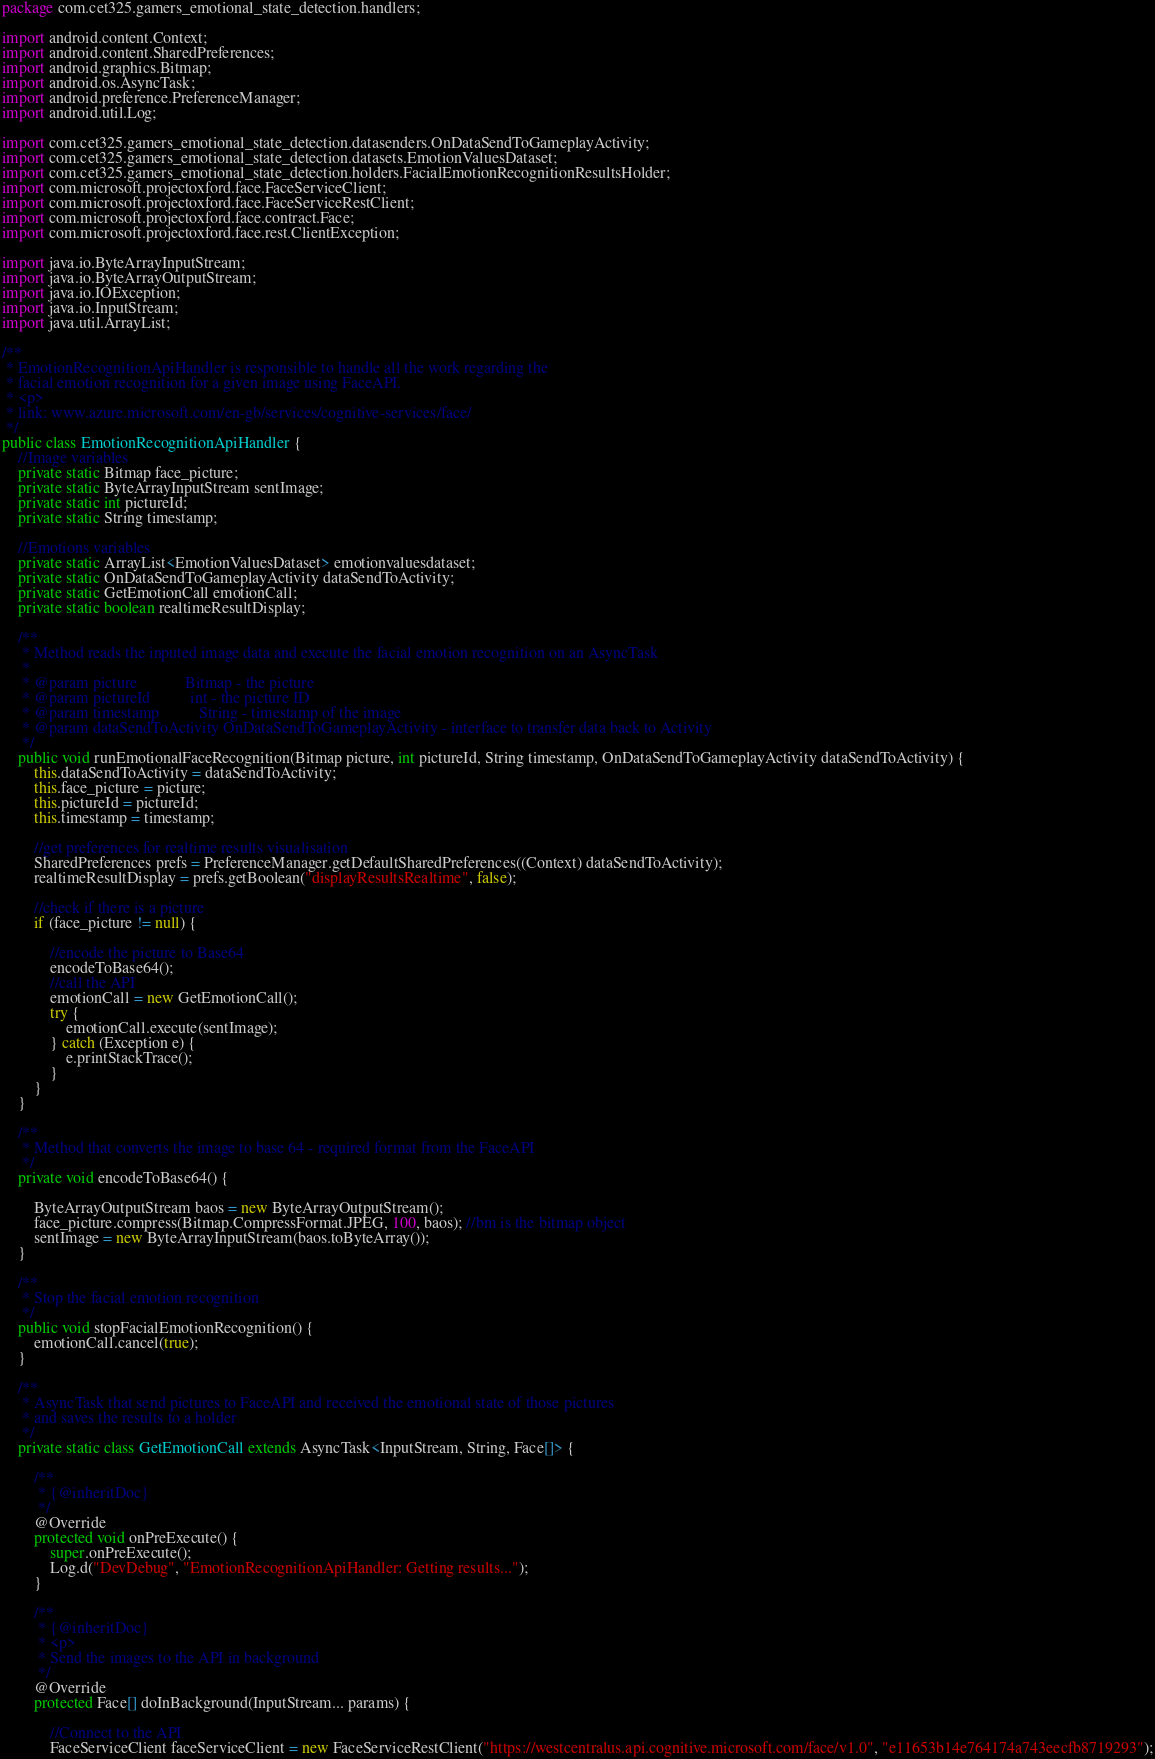Convert code to text. <code><loc_0><loc_0><loc_500><loc_500><_Java_>package com.cet325.gamers_emotional_state_detection.handlers;

import android.content.Context;
import android.content.SharedPreferences;
import android.graphics.Bitmap;
import android.os.AsyncTask;
import android.preference.PreferenceManager;
import android.util.Log;

import com.cet325.gamers_emotional_state_detection.datasenders.OnDataSendToGameplayActivity;
import com.cet325.gamers_emotional_state_detection.datasets.EmotionValuesDataset;
import com.cet325.gamers_emotional_state_detection.holders.FacialEmotionRecognitionResultsHolder;
import com.microsoft.projectoxford.face.FaceServiceClient;
import com.microsoft.projectoxford.face.FaceServiceRestClient;
import com.microsoft.projectoxford.face.contract.Face;
import com.microsoft.projectoxford.face.rest.ClientException;

import java.io.ByteArrayInputStream;
import java.io.ByteArrayOutputStream;
import java.io.IOException;
import java.io.InputStream;
import java.util.ArrayList;

/**
 * EmotionRecognitionApiHandler is responsible to handle all the work regarding the
 * facial emotion recognition for a given image using FaceAPI.
 * <p>
 * link: www.azure.microsoft.com/en-gb/services/cognitive-services/face/
 */
public class EmotionRecognitionApiHandler {
    //Image variables
    private static Bitmap face_picture;
    private static ByteArrayInputStream sentImage;
    private static int pictureId;
    private static String timestamp;

    //Emotions variables
    private static ArrayList<EmotionValuesDataset> emotionvaluesdataset;
    private static OnDataSendToGameplayActivity dataSendToActivity;
    private static GetEmotionCall emotionCall;
    private static boolean realtimeResultDisplay;

    /**
     * Method reads the inputed image data and execute the facial emotion recognition on an AsyncTask
     *
     * @param picture            Bitmap - the picture
     * @param pictureId          int - the picture ID
     * @param timestamp          String - timestamp of the image
     * @param dataSendToActivity OnDataSendToGameplayActivity - interface to transfer data back to Activity
     */
    public void runEmotionalFaceRecognition(Bitmap picture, int pictureId, String timestamp, OnDataSendToGameplayActivity dataSendToActivity) {
        this.dataSendToActivity = dataSendToActivity;
        this.face_picture = picture;
        this.pictureId = pictureId;
        this.timestamp = timestamp;

        //get preferences for realtime results visualisation
        SharedPreferences prefs = PreferenceManager.getDefaultSharedPreferences((Context) dataSendToActivity);
        realtimeResultDisplay = prefs.getBoolean("displayResultsRealtime", false);

        //check if there is a picture
        if (face_picture != null) {

            //encode the picture to Base64
            encodeToBase64();
            //call the API
            emotionCall = new GetEmotionCall();
            try {
                emotionCall.execute(sentImage);
            } catch (Exception e) {
                e.printStackTrace();
            }
        }
    }

    /**
     * Method that converts the image to base 64 - required format from the FaceAPI
     */
    private void encodeToBase64() {

        ByteArrayOutputStream baos = new ByteArrayOutputStream();
        face_picture.compress(Bitmap.CompressFormat.JPEG, 100, baos); //bm is the bitmap object
        sentImage = new ByteArrayInputStream(baos.toByteArray());
    }

    /**
     * Stop the facial emotion recognition
     */
    public void stopFacialEmotionRecognition() {
        emotionCall.cancel(true);
    }

    /**
     * AsyncTask that send pictures to FaceAPI and received the emotional state of those pictures
     * and saves the results to a holder
     */
    private static class GetEmotionCall extends AsyncTask<InputStream, String, Face[]> {

        /**
         * {@inheritDoc}
         */
        @Override
        protected void onPreExecute() {
            super.onPreExecute();
            Log.d("DevDebug", "EmotionRecognitionApiHandler: Getting results...");
        }

        /**
         * {@inheritDoc}
         * <p>
         * Send the images to the API in background
         */
        @Override
        protected Face[] doInBackground(InputStream... params) {

            //Connect to the API
            FaceServiceClient faceServiceClient = new FaceServiceRestClient("https://westcentralus.api.cognitive.microsoft.com/face/v1.0", "e11653b14e764174a743eecfb8719293");
</code> 